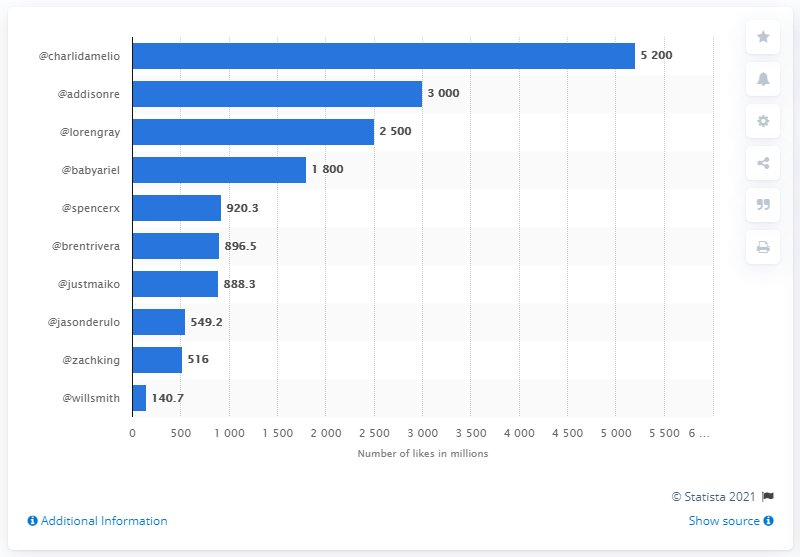Can you tell me how many more likes Charli D'Amelio has compared to the least liked creator on the chart? Charli D'Amelio has approximately 5200 million likes while the least liked creator on the chart, Will Smith, has about 140.7 million likes. Therefore, Charli D'Amelio has roughly 5059.3 million more likes than Will Smith. 